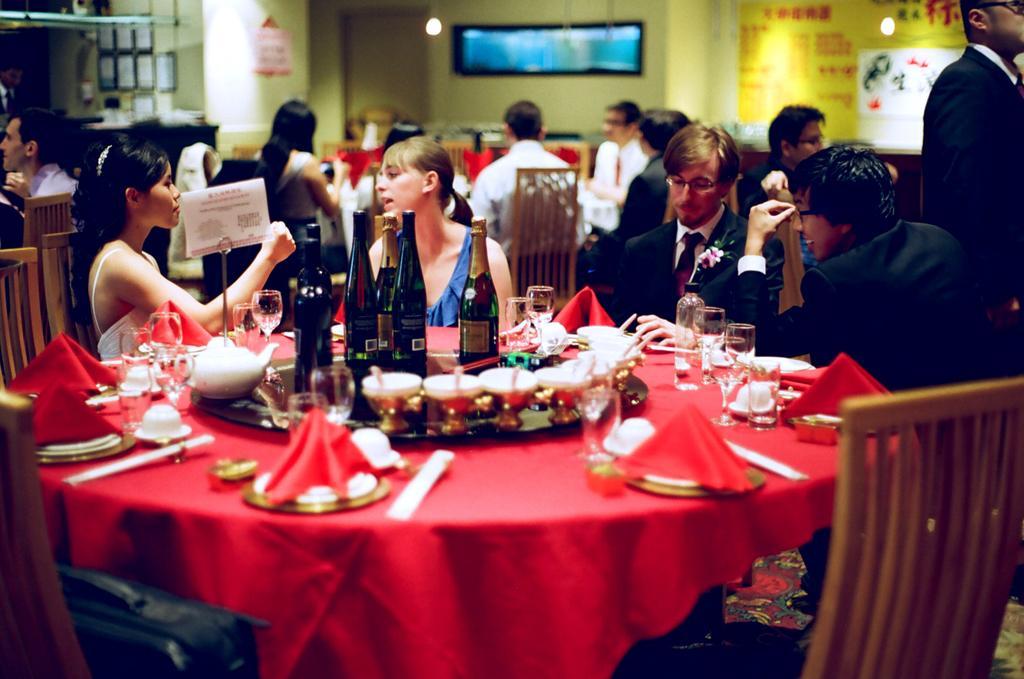Please provide a concise description of this image. In this image, there are group of people sitting on the chair in front of the table on which bottles, plates, bowls and food items are kept. In the background, there is a screen. In the left window is visible. In the right, wall paintings are visible. This image is taken inside a restaurant. 